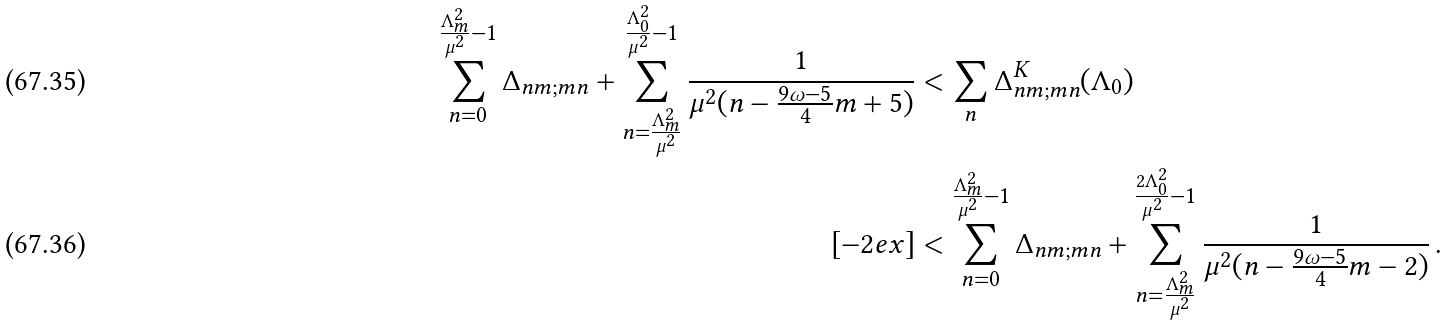Convert formula to latex. <formula><loc_0><loc_0><loc_500><loc_500>\sum _ { n = 0 } ^ { \frac { \Lambda _ { m } ^ { 2 } } { \mu ^ { 2 } } - 1 } \Delta _ { n m ; m n } + \sum _ { n = \frac { \Lambda _ { m } ^ { 2 } } { \mu ^ { 2 } } } ^ { \frac { \Lambda _ { 0 } ^ { 2 } } { \mu ^ { 2 } } - 1 } \frac { 1 } { \mu ^ { 2 } ( n - \frac { 9 \omega - 5 } { 4 } m + 5 ) } & < \sum _ { n } \Delta ^ { K } _ { n m ; m n } ( \Lambda _ { 0 } ) \\ [ - 2 e x ] & < \sum _ { n = 0 } ^ { \frac { \Lambda _ { m } ^ { 2 } } { \mu ^ { 2 } } - 1 } \Delta _ { n m ; m n } + \sum _ { n = \frac { \Lambda _ { m } ^ { 2 } } { \mu ^ { 2 } } } ^ { \frac { 2 \Lambda _ { 0 } ^ { 2 } } { \mu ^ { 2 } } - 1 } \frac { 1 } { \mu ^ { 2 } ( n - \frac { 9 \omega - 5 } { 4 } m - 2 ) } \, .</formula> 